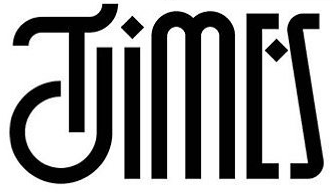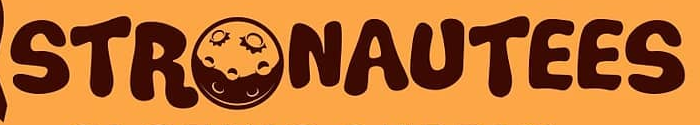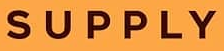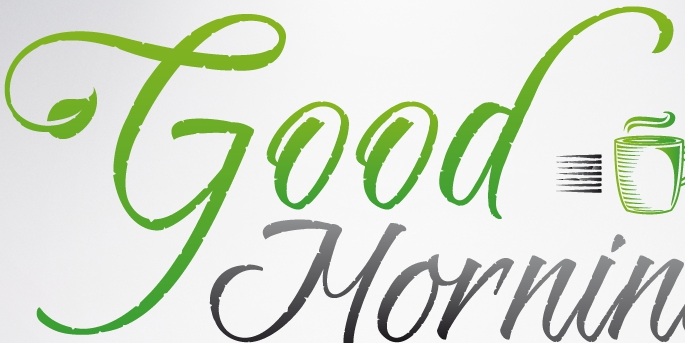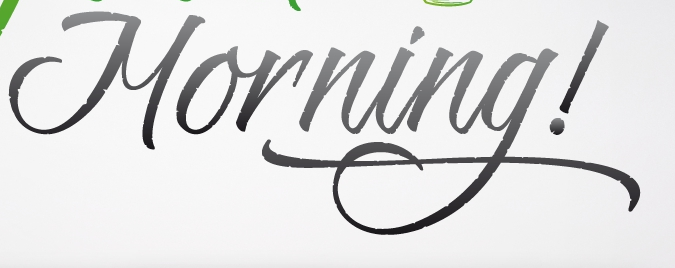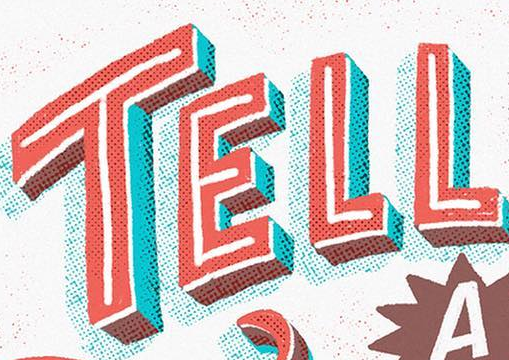What words can you see in these images in sequence, separated by a semicolon? TIMES; STRONAUTEES; SUPPLY; Good; Morning!; TELL 